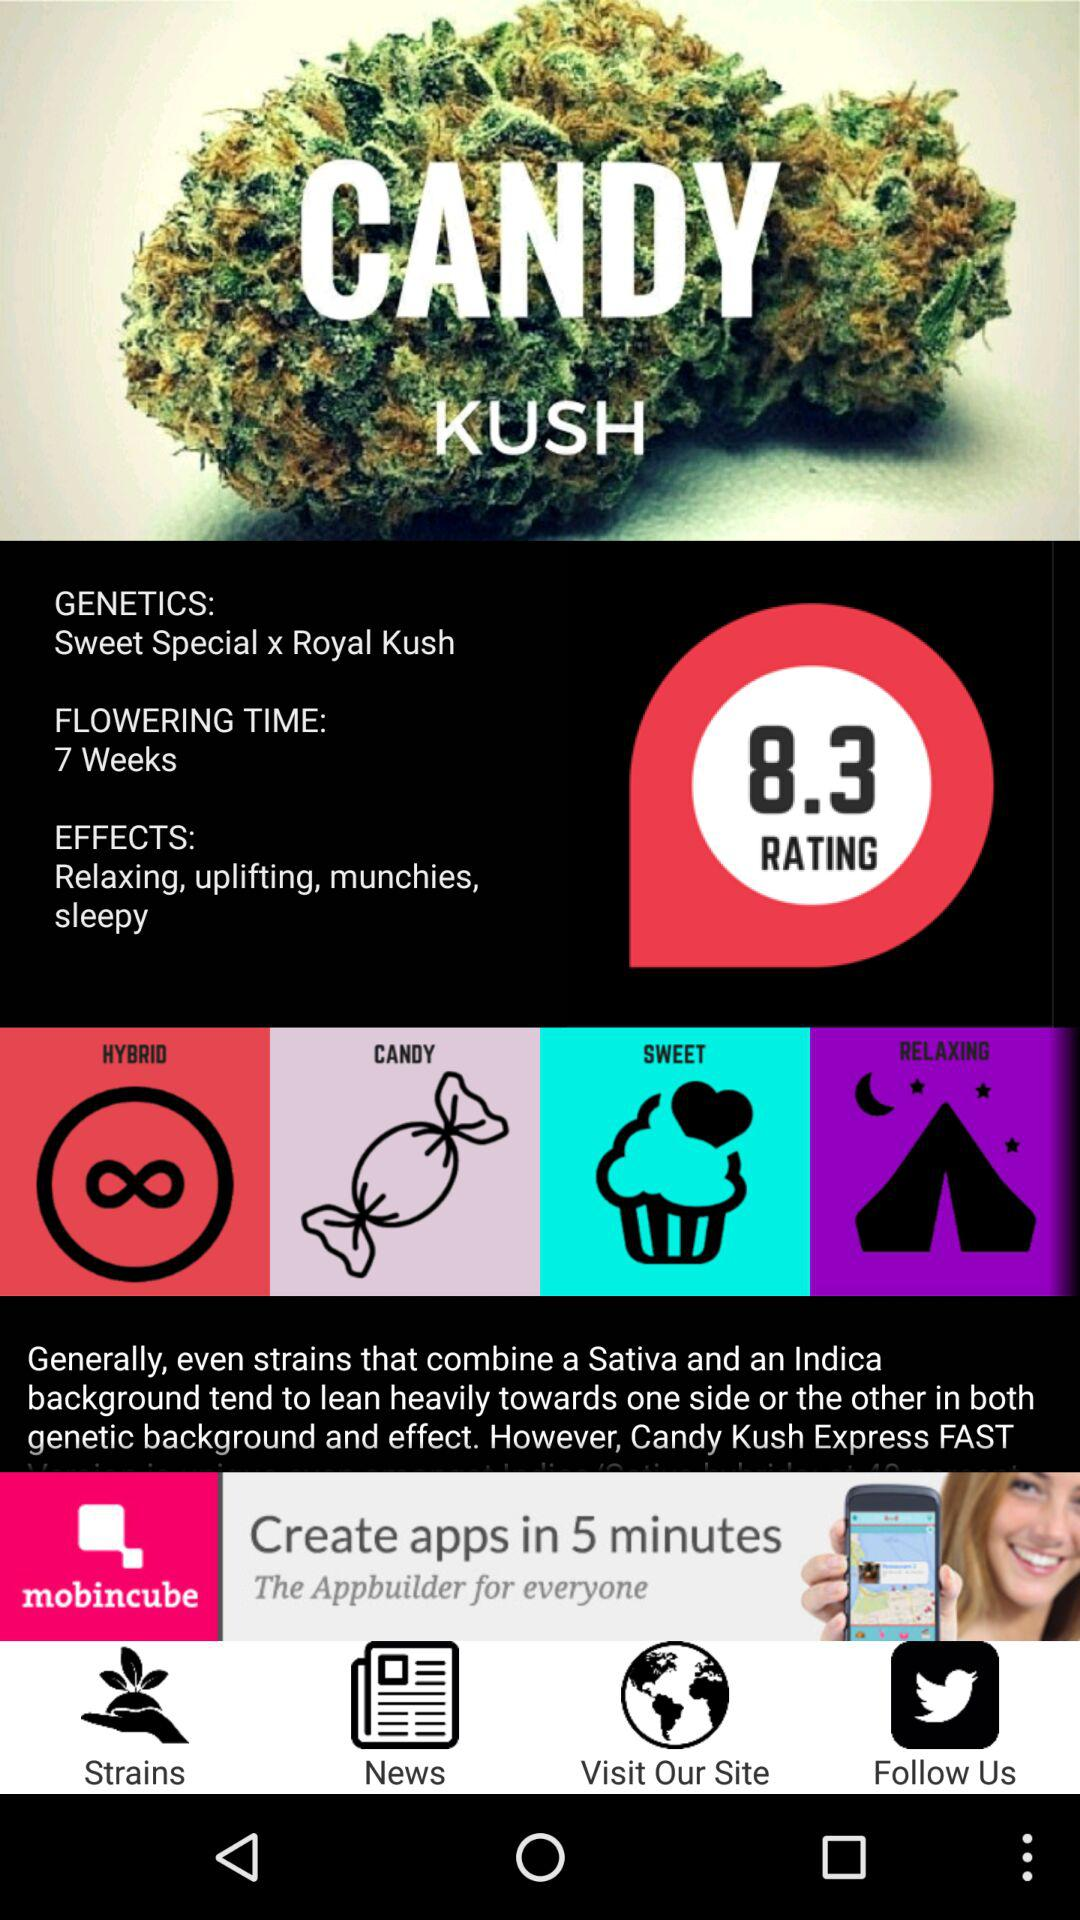What is the fourth effect of Candy Kush Express?
Answer the question using a single word or phrase. Sleepy 